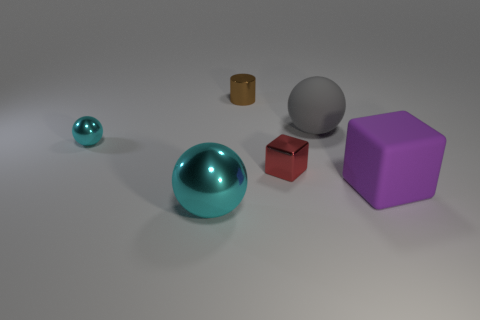Subtract all cyan balls. How many balls are left? 1 Add 2 purple rubber things. How many objects exist? 8 Subtract all cyan cubes. How many cyan spheres are left? 2 Subtract all red cubes. How many cubes are left? 1 Subtract all blocks. How many objects are left? 4 Subtract 2 balls. How many balls are left? 1 Subtract all cyan cylinders. Subtract all green balls. How many cylinders are left? 1 Subtract all big gray rubber things. Subtract all small things. How many objects are left? 2 Add 5 large cyan metal things. How many large cyan metal things are left? 6 Add 6 small metal balls. How many small metal balls exist? 7 